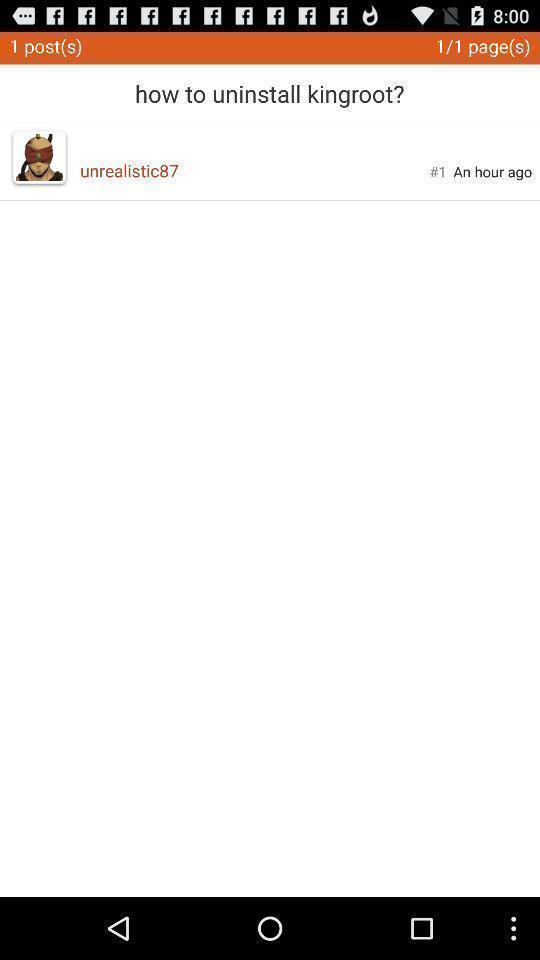Describe the visual elements of this screenshot. Screen displaying about how to uninstall the app. 